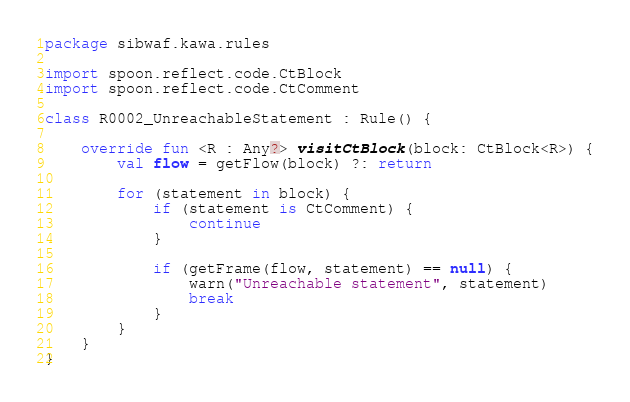<code> <loc_0><loc_0><loc_500><loc_500><_Kotlin_>package sibwaf.kawa.rules

import spoon.reflect.code.CtBlock
import spoon.reflect.code.CtComment

class R0002_UnreachableStatement : Rule() {

    override fun <R : Any?> visitCtBlock(block: CtBlock<R>) {
        val flow = getFlow(block) ?: return

        for (statement in block) {
            if (statement is CtComment) {
                continue
            }

            if (getFrame(flow, statement) == null) {
                warn("Unreachable statement", statement)
                break
            }
        }
    }
}</code> 